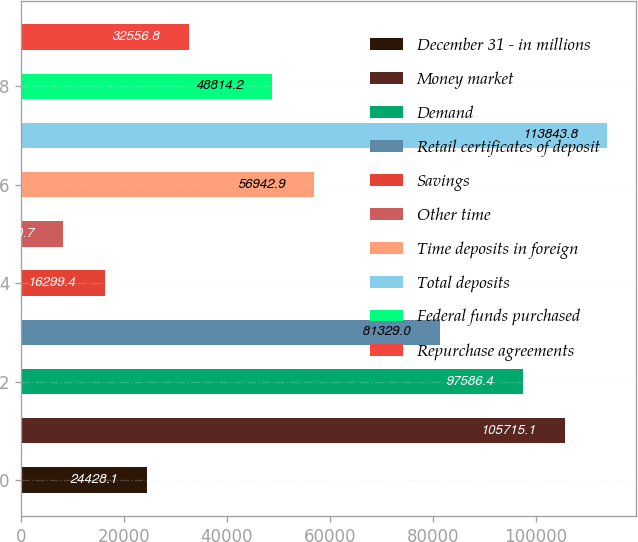Convert chart. <chart><loc_0><loc_0><loc_500><loc_500><bar_chart><fcel>December 31 - in millions<fcel>Money market<fcel>Demand<fcel>Retail certificates of deposit<fcel>Savings<fcel>Other time<fcel>Time deposits in foreign<fcel>Total deposits<fcel>Federal funds purchased<fcel>Repurchase agreements<nl><fcel>24428.1<fcel>105715<fcel>97586.4<fcel>81329<fcel>16299.4<fcel>8170.7<fcel>56942.9<fcel>113844<fcel>48814.2<fcel>32556.8<nl></chart> 